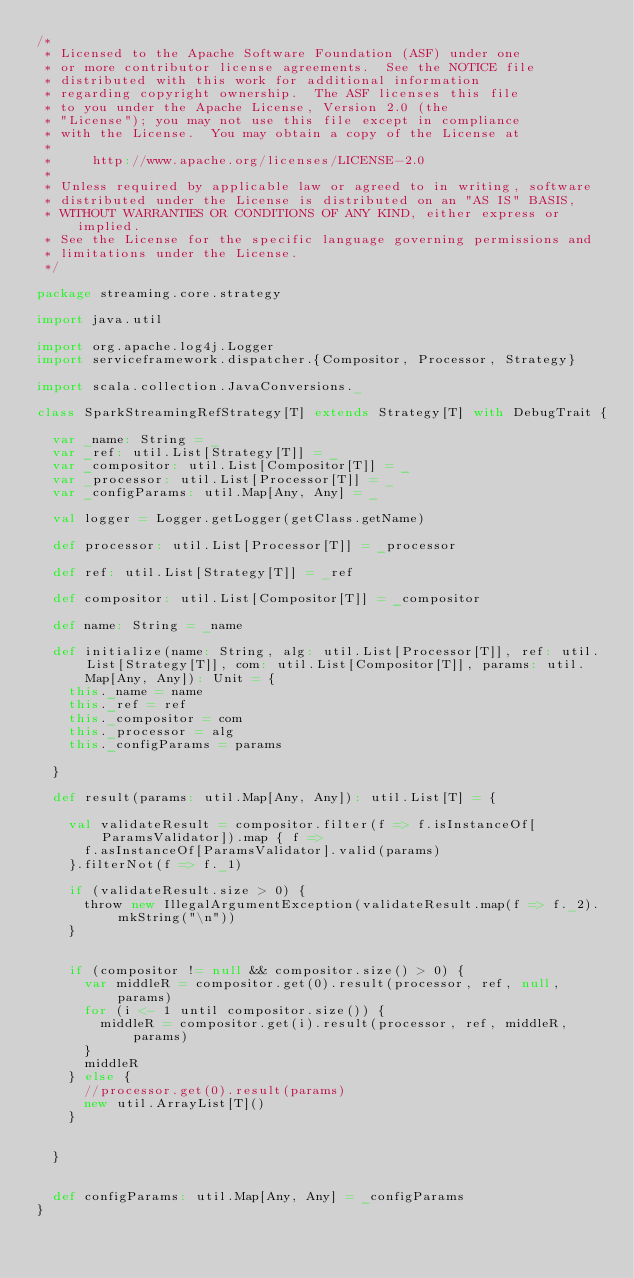Convert code to text. <code><loc_0><loc_0><loc_500><loc_500><_Scala_>/*
 * Licensed to the Apache Software Foundation (ASF) under one
 * or more contributor license agreements.  See the NOTICE file
 * distributed with this work for additional information
 * regarding copyright ownership.  The ASF licenses this file
 * to you under the Apache License, Version 2.0 (the
 * "License"); you may not use this file except in compliance
 * with the License.  You may obtain a copy of the License at
 *
 *     http://www.apache.org/licenses/LICENSE-2.0
 *
 * Unless required by applicable law or agreed to in writing, software
 * distributed under the License is distributed on an "AS IS" BASIS,
 * WITHOUT WARRANTIES OR CONDITIONS OF ANY KIND, either express or implied.
 * See the License for the specific language governing permissions and
 * limitations under the License.
 */

package streaming.core.strategy

import java.util

import org.apache.log4j.Logger
import serviceframework.dispatcher.{Compositor, Processor, Strategy}

import scala.collection.JavaConversions._

class SparkStreamingRefStrategy[T] extends Strategy[T] with DebugTrait {

  var _name: String = _
  var _ref: util.List[Strategy[T]] = _
  var _compositor: util.List[Compositor[T]] = _
  var _processor: util.List[Processor[T]] = _
  var _configParams: util.Map[Any, Any] = _

  val logger = Logger.getLogger(getClass.getName)

  def processor: util.List[Processor[T]] = _processor

  def ref: util.List[Strategy[T]] = _ref

  def compositor: util.List[Compositor[T]] = _compositor

  def name: String = _name

  def initialize(name: String, alg: util.List[Processor[T]], ref: util.List[Strategy[T]], com: util.List[Compositor[T]], params: util.Map[Any, Any]): Unit = {
    this._name = name
    this._ref = ref
    this._compositor = com
    this._processor = alg
    this._configParams = params

  }

  def result(params: util.Map[Any, Any]): util.List[T] = {

    val validateResult = compositor.filter(f => f.isInstanceOf[ParamsValidator]).map { f =>
      f.asInstanceOf[ParamsValidator].valid(params)
    }.filterNot(f => f._1)

    if (validateResult.size > 0) {
      throw new IllegalArgumentException(validateResult.map(f => f._2).mkString("\n"))
    }


    if (compositor != null && compositor.size() > 0) {
      var middleR = compositor.get(0).result(processor, ref, null, params)
      for (i <- 1 until compositor.size()) {
        middleR = compositor.get(i).result(processor, ref, middleR, params)
      }
      middleR
    } else {
      //processor.get(0).result(params)
      new util.ArrayList[T]()
    }


  }


  def configParams: util.Map[Any, Any] = _configParams
}
</code> 